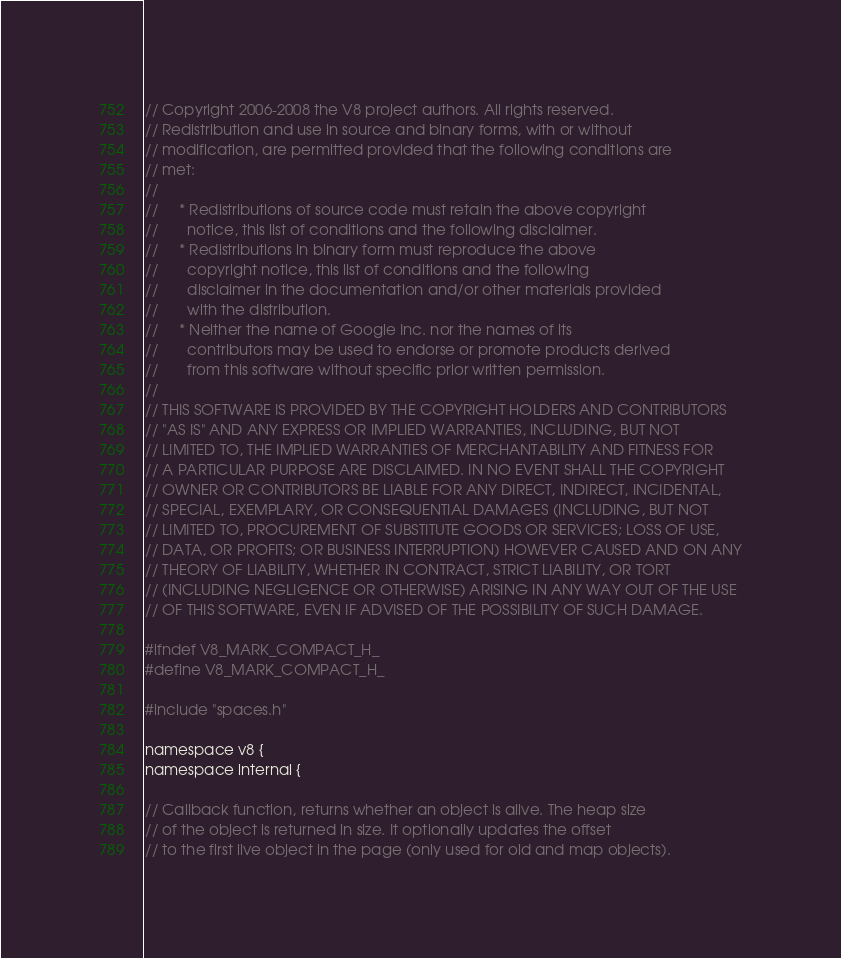<code> <loc_0><loc_0><loc_500><loc_500><_C_>// Copyright 2006-2008 the V8 project authors. All rights reserved.
// Redistribution and use in source and binary forms, with or without
// modification, are permitted provided that the following conditions are
// met:
//
//     * Redistributions of source code must retain the above copyright
//       notice, this list of conditions and the following disclaimer.
//     * Redistributions in binary form must reproduce the above
//       copyright notice, this list of conditions and the following
//       disclaimer in the documentation and/or other materials provided
//       with the distribution.
//     * Neither the name of Google Inc. nor the names of its
//       contributors may be used to endorse or promote products derived
//       from this software without specific prior written permission.
//
// THIS SOFTWARE IS PROVIDED BY THE COPYRIGHT HOLDERS AND CONTRIBUTORS
// "AS IS" AND ANY EXPRESS OR IMPLIED WARRANTIES, INCLUDING, BUT NOT
// LIMITED TO, THE IMPLIED WARRANTIES OF MERCHANTABILITY AND FITNESS FOR
// A PARTICULAR PURPOSE ARE DISCLAIMED. IN NO EVENT SHALL THE COPYRIGHT
// OWNER OR CONTRIBUTORS BE LIABLE FOR ANY DIRECT, INDIRECT, INCIDENTAL,
// SPECIAL, EXEMPLARY, OR CONSEQUENTIAL DAMAGES (INCLUDING, BUT NOT
// LIMITED TO, PROCUREMENT OF SUBSTITUTE GOODS OR SERVICES; LOSS OF USE,
// DATA, OR PROFITS; OR BUSINESS INTERRUPTION) HOWEVER CAUSED AND ON ANY
// THEORY OF LIABILITY, WHETHER IN CONTRACT, STRICT LIABILITY, OR TORT
// (INCLUDING NEGLIGENCE OR OTHERWISE) ARISING IN ANY WAY OUT OF THE USE
// OF THIS SOFTWARE, EVEN IF ADVISED OF THE POSSIBILITY OF SUCH DAMAGE.

#ifndef V8_MARK_COMPACT_H_
#define V8_MARK_COMPACT_H_

#include "spaces.h"

namespace v8 {
namespace internal {

// Callback function, returns whether an object is alive. The heap size
// of the object is returned in size. It optionally updates the offset
// to the first live object in the page (only used for old and map objects).</code> 